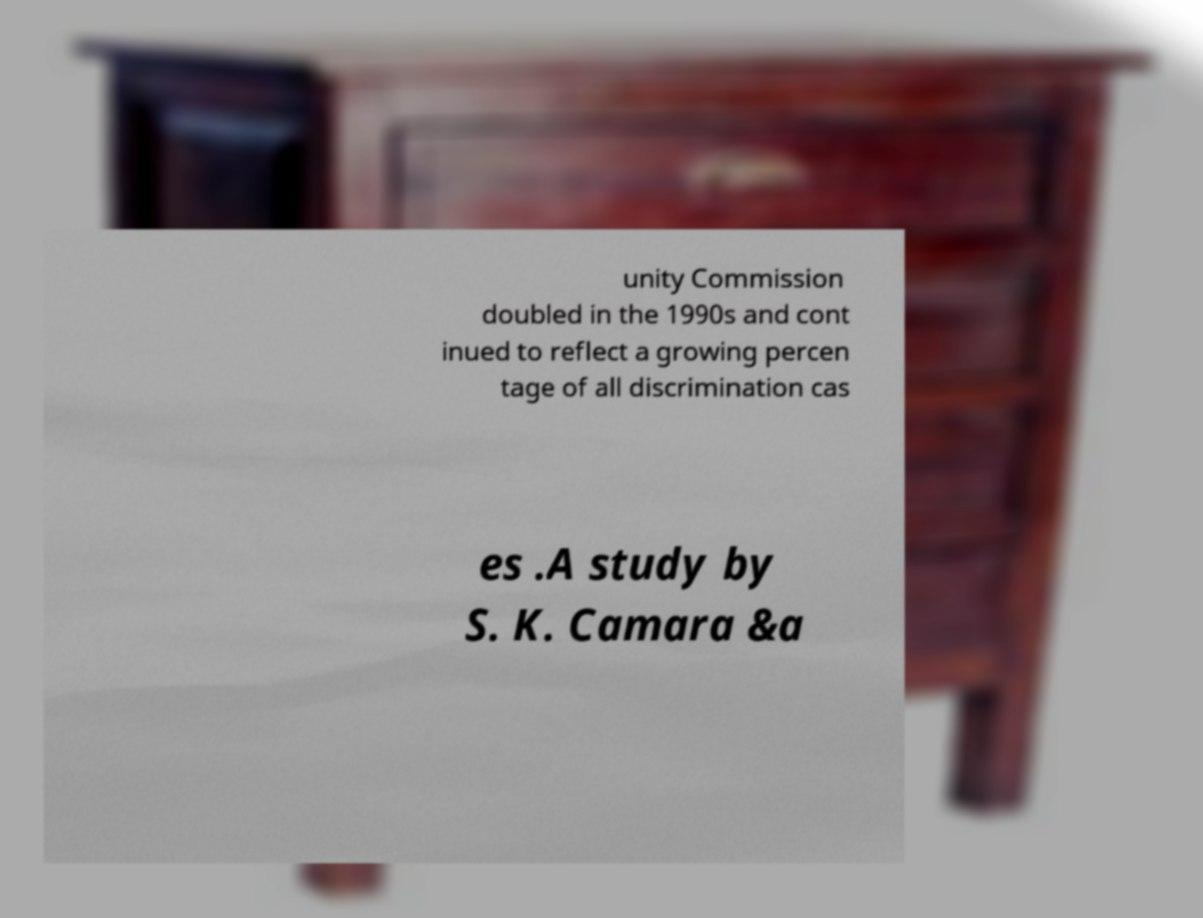Can you accurately transcribe the text from the provided image for me? unity Commission doubled in the 1990s and cont inued to reflect a growing percen tage of all discrimination cas es .A study by S. K. Camara &a 